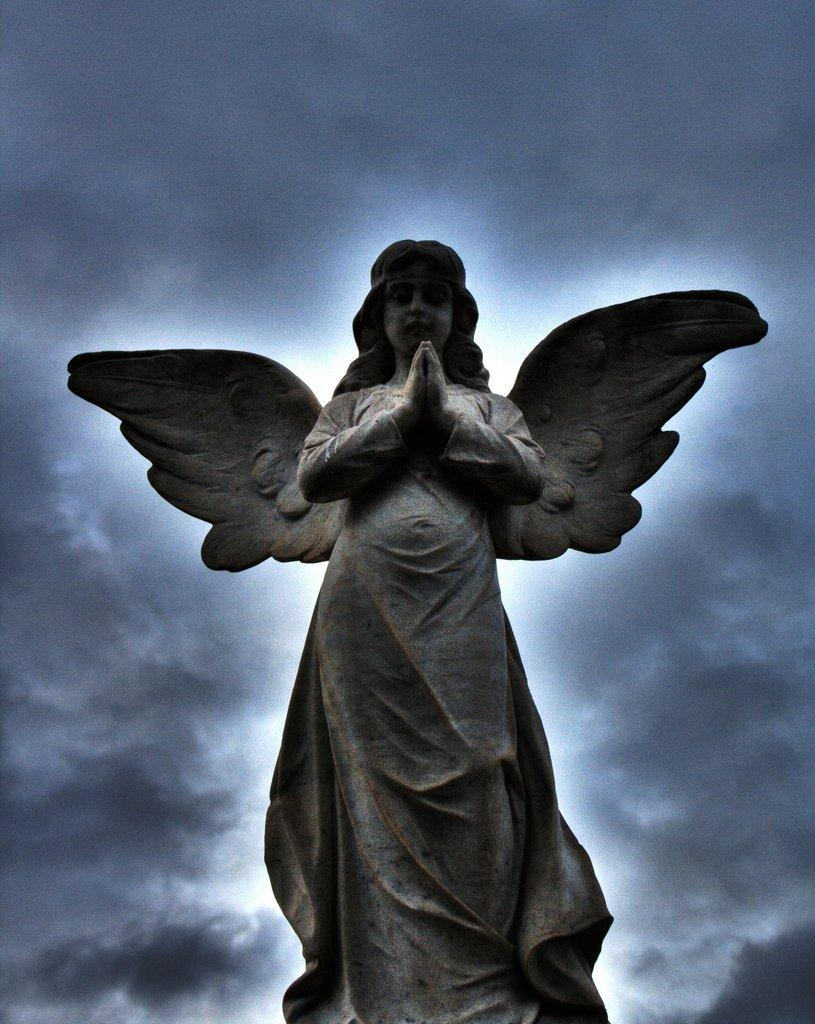What is the main subject of the image? There is a sculpture of an angel in the image. Can you describe the sculpture in more detail? The sculpture is of an angel, which is a spiritual or religious figure. What material might the sculpture be made of? The material of the sculpture is not specified in the facts, but it could be made of stone, metal, or other materials commonly used for sculptures. Is there a volcano erupting in the background of the image? No, there is no mention of a volcano or any eruption in the image. The image only features a sculpture of an angel. 